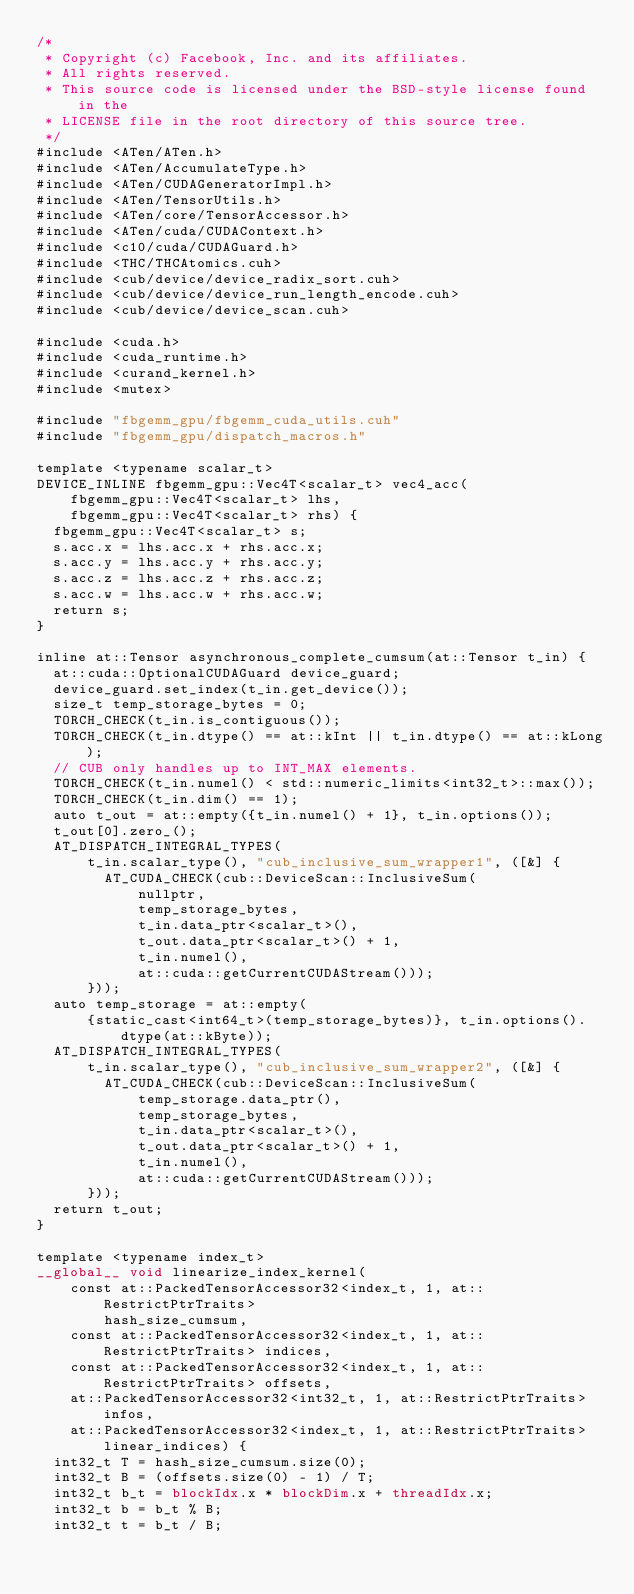Convert code to text. <code><loc_0><loc_0><loc_500><loc_500><_Cuda_>/*
 * Copyright (c) Facebook, Inc. and its affiliates.
 * All rights reserved.
 * This source code is licensed under the BSD-style license found in the
 * LICENSE file in the root directory of this source tree.
 */
#include <ATen/ATen.h>
#include <ATen/AccumulateType.h>
#include <ATen/CUDAGeneratorImpl.h>
#include <ATen/TensorUtils.h>
#include <ATen/core/TensorAccessor.h>
#include <ATen/cuda/CUDAContext.h>
#include <c10/cuda/CUDAGuard.h>
#include <THC/THCAtomics.cuh>
#include <cub/device/device_radix_sort.cuh>
#include <cub/device/device_run_length_encode.cuh>
#include <cub/device/device_scan.cuh>

#include <cuda.h>
#include <cuda_runtime.h>
#include <curand_kernel.h>
#include <mutex>

#include "fbgemm_gpu/fbgemm_cuda_utils.cuh"
#include "fbgemm_gpu/dispatch_macros.h"

template <typename scalar_t>
DEVICE_INLINE fbgemm_gpu::Vec4T<scalar_t> vec4_acc(
    fbgemm_gpu::Vec4T<scalar_t> lhs,
    fbgemm_gpu::Vec4T<scalar_t> rhs) {
  fbgemm_gpu::Vec4T<scalar_t> s;
  s.acc.x = lhs.acc.x + rhs.acc.x;
  s.acc.y = lhs.acc.y + rhs.acc.y;
  s.acc.z = lhs.acc.z + rhs.acc.z;
  s.acc.w = lhs.acc.w + rhs.acc.w;
  return s;
}

inline at::Tensor asynchronous_complete_cumsum(at::Tensor t_in) {
  at::cuda::OptionalCUDAGuard device_guard;
  device_guard.set_index(t_in.get_device());
  size_t temp_storage_bytes = 0;
  TORCH_CHECK(t_in.is_contiguous());
  TORCH_CHECK(t_in.dtype() == at::kInt || t_in.dtype() == at::kLong);
  // CUB only handles up to INT_MAX elements.
  TORCH_CHECK(t_in.numel() < std::numeric_limits<int32_t>::max());
  TORCH_CHECK(t_in.dim() == 1);
  auto t_out = at::empty({t_in.numel() + 1}, t_in.options());
  t_out[0].zero_();
  AT_DISPATCH_INTEGRAL_TYPES(
      t_in.scalar_type(), "cub_inclusive_sum_wrapper1", ([&] {
        AT_CUDA_CHECK(cub::DeviceScan::InclusiveSum(
            nullptr,
            temp_storage_bytes,
            t_in.data_ptr<scalar_t>(),
            t_out.data_ptr<scalar_t>() + 1,
            t_in.numel(),
            at::cuda::getCurrentCUDAStream()));
      }));
  auto temp_storage = at::empty(
      {static_cast<int64_t>(temp_storage_bytes)}, t_in.options().dtype(at::kByte));
  AT_DISPATCH_INTEGRAL_TYPES(
      t_in.scalar_type(), "cub_inclusive_sum_wrapper2", ([&] {
        AT_CUDA_CHECK(cub::DeviceScan::InclusiveSum(
            temp_storage.data_ptr(),
            temp_storage_bytes,
            t_in.data_ptr<scalar_t>(),
            t_out.data_ptr<scalar_t>() + 1,
            t_in.numel(),
            at::cuda::getCurrentCUDAStream()));
      }));
  return t_out;
}

template <typename index_t>
__global__ void linearize_index_kernel(
    const at::PackedTensorAccessor32<index_t, 1, at::RestrictPtrTraits>
        hash_size_cumsum,
    const at::PackedTensorAccessor32<index_t, 1, at::RestrictPtrTraits> indices,
    const at::PackedTensorAccessor32<index_t, 1, at::RestrictPtrTraits> offsets,
    at::PackedTensorAccessor32<int32_t, 1, at::RestrictPtrTraits> infos,
    at::PackedTensorAccessor32<index_t, 1, at::RestrictPtrTraits> linear_indices) {
  int32_t T = hash_size_cumsum.size(0);
  int32_t B = (offsets.size(0) - 1) / T;
  int32_t b_t = blockIdx.x * blockDim.x + threadIdx.x;
  int32_t b = b_t % B;
  int32_t t = b_t / B;</code> 